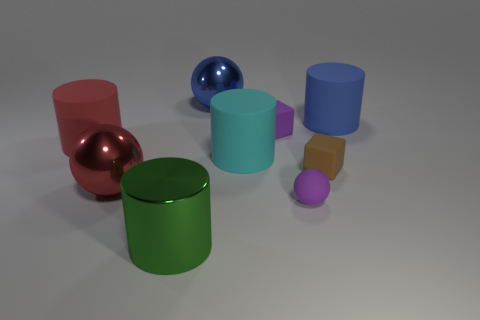Subtract all green metallic cylinders. How many cylinders are left? 3 Subtract 2 balls. How many balls are left? 1 Add 1 green metallic objects. How many objects exist? 10 Subtract all purple balls. How many balls are left? 2 Subtract all blocks. How many objects are left? 7 Add 7 tiny rubber balls. How many tiny rubber balls exist? 8 Subtract 0 yellow blocks. How many objects are left? 9 Subtract all red balls. Subtract all gray blocks. How many balls are left? 2 Subtract all purple rubber cylinders. Subtract all shiny cylinders. How many objects are left? 8 Add 1 tiny objects. How many tiny objects are left? 4 